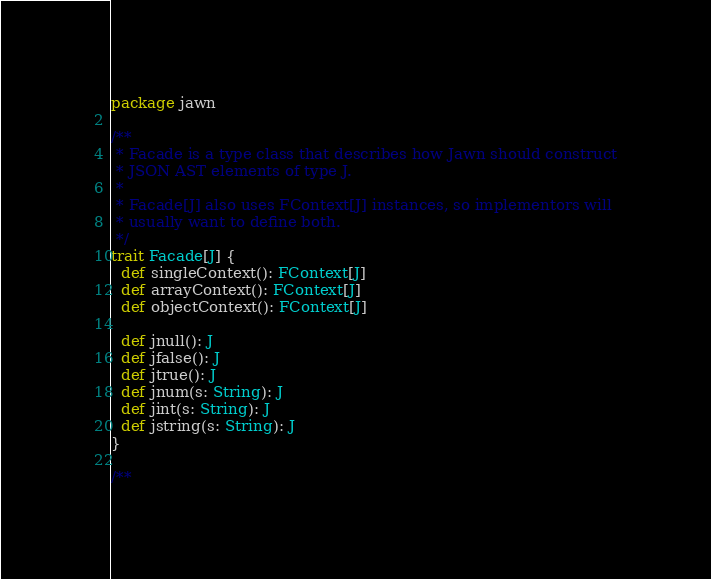<code> <loc_0><loc_0><loc_500><loc_500><_Scala_>package jawn

/**
 * Facade is a type class that describes how Jawn should construct
 * JSON AST elements of type J.
 * 
 * Facade[J] also uses FContext[J] instances, so implementors will
 * usually want to define both.
 */
trait Facade[J] {
  def singleContext(): FContext[J]
  def arrayContext(): FContext[J]
  def objectContext(): FContext[J]

  def jnull(): J
  def jfalse(): J
  def jtrue(): J
  def jnum(s: String): J
  def jint(s: String): J
  def jstring(s: String): J
}

/**</code> 